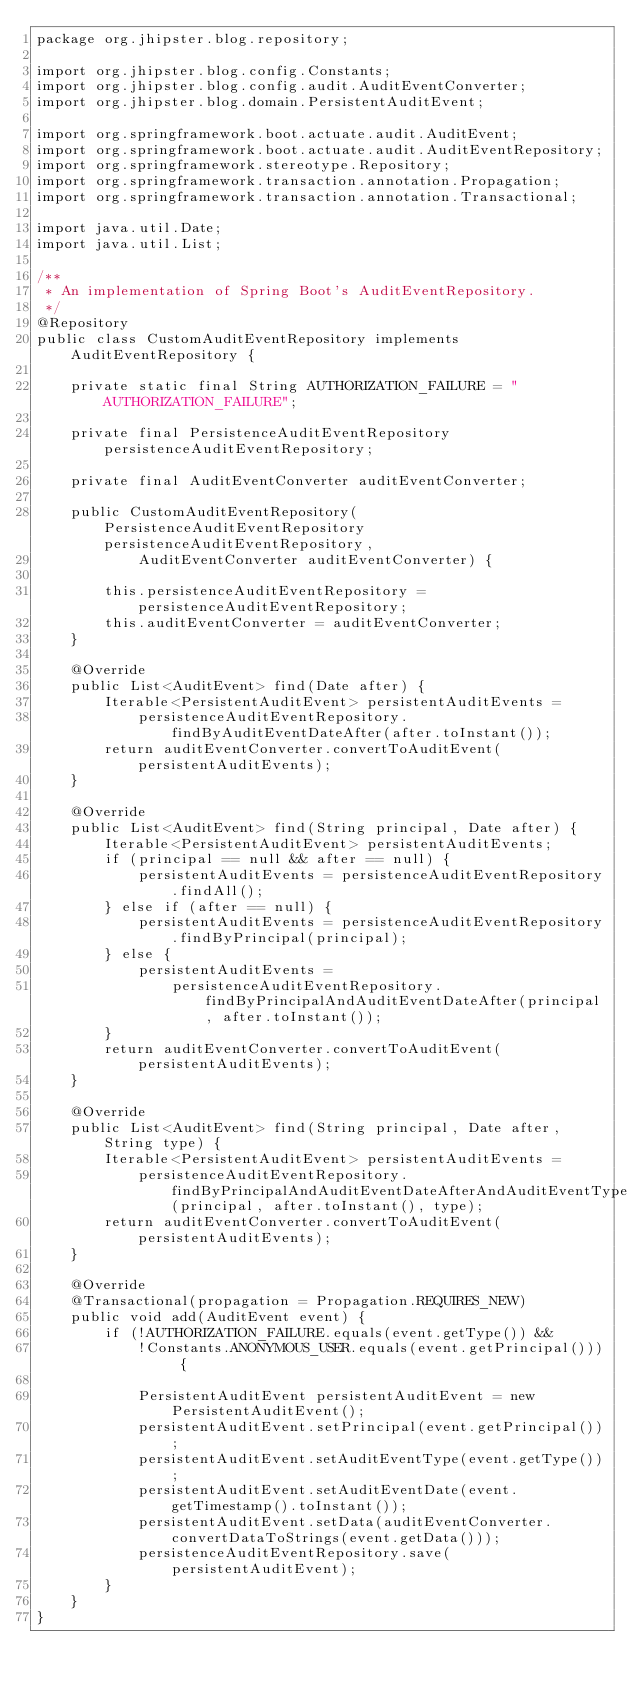<code> <loc_0><loc_0><loc_500><loc_500><_Java_>package org.jhipster.blog.repository;

import org.jhipster.blog.config.Constants;
import org.jhipster.blog.config.audit.AuditEventConverter;
import org.jhipster.blog.domain.PersistentAuditEvent;

import org.springframework.boot.actuate.audit.AuditEvent;
import org.springframework.boot.actuate.audit.AuditEventRepository;
import org.springframework.stereotype.Repository;
import org.springframework.transaction.annotation.Propagation;
import org.springframework.transaction.annotation.Transactional;

import java.util.Date;
import java.util.List;

/**
 * An implementation of Spring Boot's AuditEventRepository.
 */
@Repository
public class CustomAuditEventRepository implements AuditEventRepository {

    private static final String AUTHORIZATION_FAILURE = "AUTHORIZATION_FAILURE";

    private final PersistenceAuditEventRepository persistenceAuditEventRepository;

    private final AuditEventConverter auditEventConverter;

    public CustomAuditEventRepository(PersistenceAuditEventRepository persistenceAuditEventRepository,
            AuditEventConverter auditEventConverter) {

        this.persistenceAuditEventRepository = persistenceAuditEventRepository;
        this.auditEventConverter = auditEventConverter;
    }

    @Override
    public List<AuditEvent> find(Date after) {
        Iterable<PersistentAuditEvent> persistentAuditEvents =
            persistenceAuditEventRepository.findByAuditEventDateAfter(after.toInstant());
        return auditEventConverter.convertToAuditEvent(persistentAuditEvents);
    }

    @Override
    public List<AuditEvent> find(String principal, Date after) {
        Iterable<PersistentAuditEvent> persistentAuditEvents;
        if (principal == null && after == null) {
            persistentAuditEvents = persistenceAuditEventRepository.findAll();
        } else if (after == null) {
            persistentAuditEvents = persistenceAuditEventRepository.findByPrincipal(principal);
        } else {
            persistentAuditEvents =
                persistenceAuditEventRepository.findByPrincipalAndAuditEventDateAfter(principal, after.toInstant());
        }
        return auditEventConverter.convertToAuditEvent(persistentAuditEvents);
    }

    @Override
    public List<AuditEvent> find(String principal, Date after, String type) {
        Iterable<PersistentAuditEvent> persistentAuditEvents =
            persistenceAuditEventRepository.findByPrincipalAndAuditEventDateAfterAndAuditEventType(principal, after.toInstant(), type);
        return auditEventConverter.convertToAuditEvent(persistentAuditEvents);
    }

    @Override
    @Transactional(propagation = Propagation.REQUIRES_NEW)
    public void add(AuditEvent event) {
        if (!AUTHORIZATION_FAILURE.equals(event.getType()) &&
            !Constants.ANONYMOUS_USER.equals(event.getPrincipal())) {

            PersistentAuditEvent persistentAuditEvent = new PersistentAuditEvent();
            persistentAuditEvent.setPrincipal(event.getPrincipal());
            persistentAuditEvent.setAuditEventType(event.getType());
            persistentAuditEvent.setAuditEventDate(event.getTimestamp().toInstant());
            persistentAuditEvent.setData(auditEventConverter.convertDataToStrings(event.getData()));
            persistenceAuditEventRepository.save(persistentAuditEvent);
        }
    }
}
</code> 